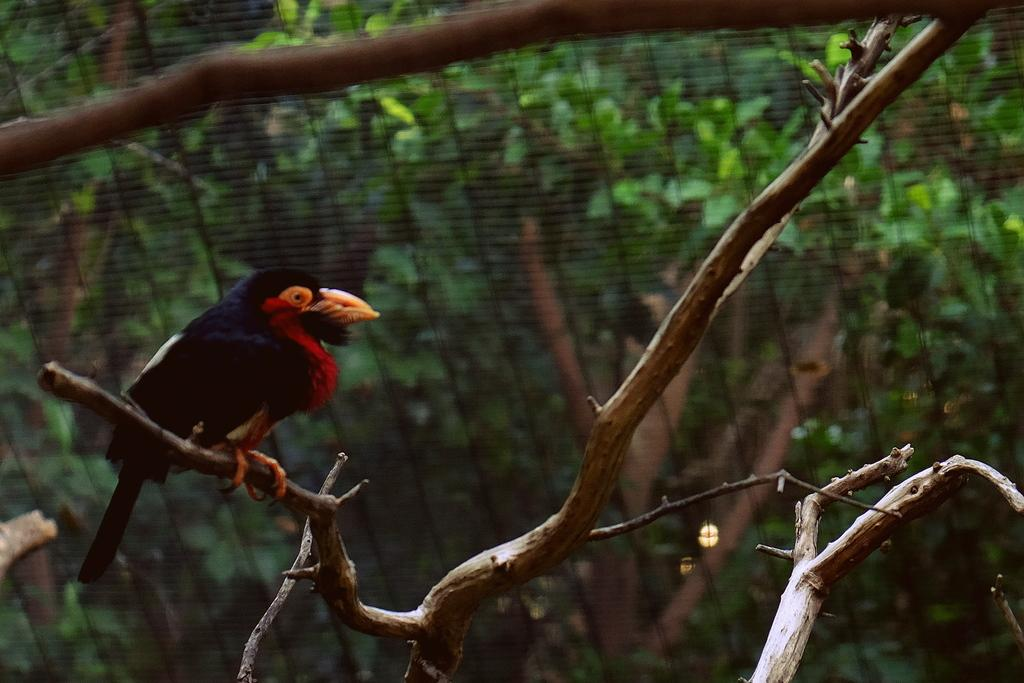What type of animal can be seen in the image? There is a bird in the image. Where is the bird located on the tree? The bird is on a tree stem. What is the main object visible in the foreground of the image? There is a grill in the image. What can be seen in the background behind the grill? There are trees visible behind the grill. What type of barrier is present in the image? There is fencing in the image. How does the bird measure the distance between the tree branches in the image? The bird does not measure the distance between tree branches in the image; it is simply perched on a tree stem. 